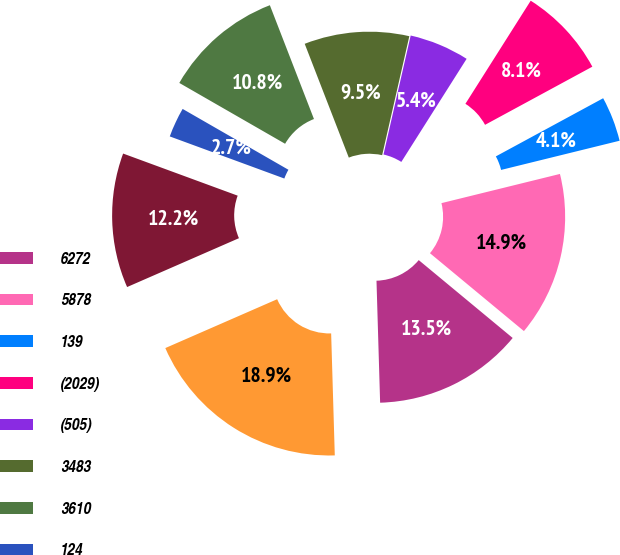Convert chart. <chart><loc_0><loc_0><loc_500><loc_500><pie_chart><fcel>6272<fcel>5878<fcel>139<fcel>(2029)<fcel>(505)<fcel>3483<fcel>3610<fcel>124<fcel>4148<fcel>49113<nl><fcel>13.51%<fcel>14.86%<fcel>4.06%<fcel>8.11%<fcel>5.41%<fcel>9.46%<fcel>10.81%<fcel>2.7%<fcel>12.16%<fcel>18.92%<nl></chart> 